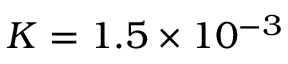Convert formula to latex. <formula><loc_0><loc_0><loc_500><loc_500>K = 1 . 5 \times 1 0 ^ { - 3 }</formula> 